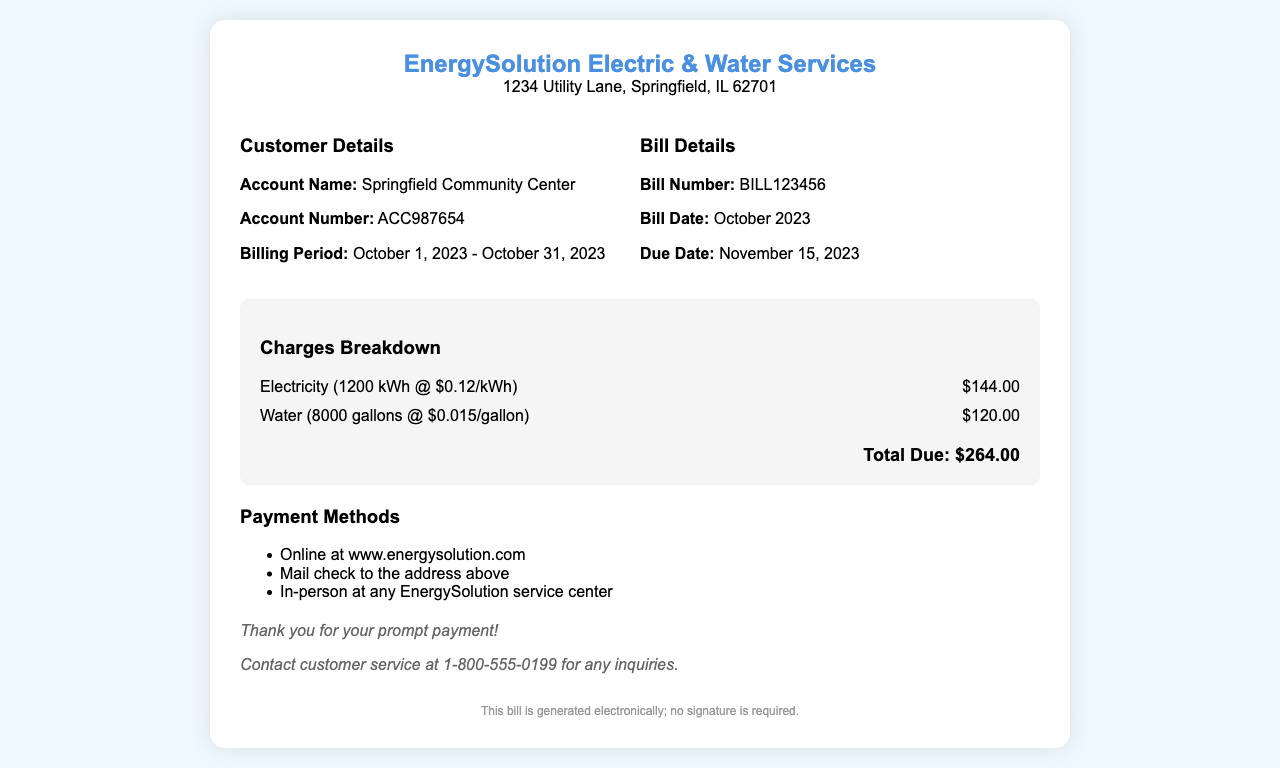What is the account name? The account name is provided in the customer details section of the document.
Answer: Springfield Community Center What is the bill number? The bill number is mentioned under the bill details section.
Answer: BILL123456 What is the total due amount? The total due is calculated from the charges breakdown section of the receipt.
Answer: $264.00 What is the billing period? The billing period is specified in the customer details section.
Answer: October 1, 2023 - October 31, 2023 How much is charged for water? The charge for water is listed in the charges breakdown.
Answer: $120.00 What is the due date for payment? The due date is indicated in the bill details section.
Answer: November 15, 2023 How many gallons of water were used? The total gallons of water used is specified in the charges breakdown.
Answer: 8000 gallons What is the electricity rate per kWh? The electricity rate is detailed in the charges breakdown.
Answer: $0.12/kWh What is the payment method mentioned for online payment? The payment method for online payment is mentioned in the payment methods section.
Answer: www.energysolution.com 